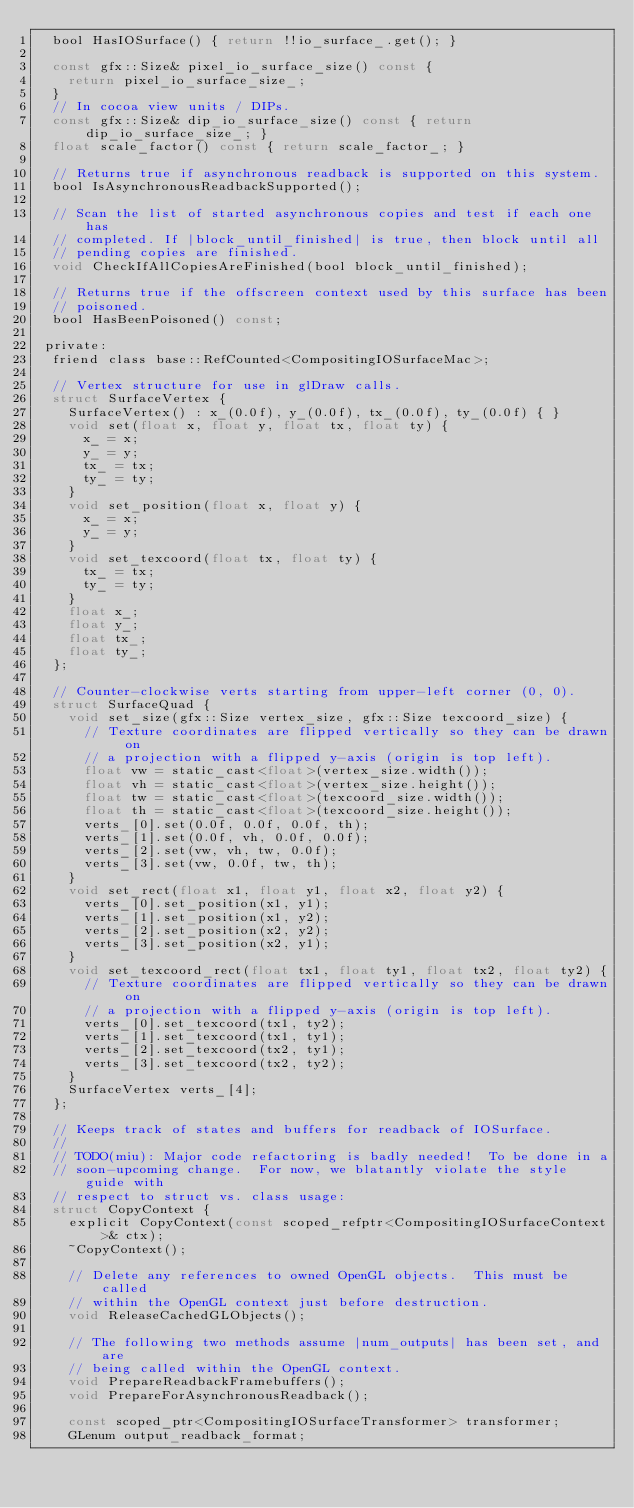Convert code to text. <code><loc_0><loc_0><loc_500><loc_500><_C_>  bool HasIOSurface() { return !!io_surface_.get(); }

  const gfx::Size& pixel_io_surface_size() const {
    return pixel_io_surface_size_;
  }
  // In cocoa view units / DIPs.
  const gfx::Size& dip_io_surface_size() const { return dip_io_surface_size_; }
  float scale_factor() const { return scale_factor_; }

  // Returns true if asynchronous readback is supported on this system.
  bool IsAsynchronousReadbackSupported();

  // Scan the list of started asynchronous copies and test if each one has
  // completed. If |block_until_finished| is true, then block until all
  // pending copies are finished.
  void CheckIfAllCopiesAreFinished(bool block_until_finished);

  // Returns true if the offscreen context used by this surface has been
  // poisoned.
  bool HasBeenPoisoned() const;

 private:
  friend class base::RefCounted<CompositingIOSurfaceMac>;

  // Vertex structure for use in glDraw calls.
  struct SurfaceVertex {
    SurfaceVertex() : x_(0.0f), y_(0.0f), tx_(0.0f), ty_(0.0f) { }
    void set(float x, float y, float tx, float ty) {
      x_ = x;
      y_ = y;
      tx_ = tx;
      ty_ = ty;
    }
    void set_position(float x, float y) {
      x_ = x;
      y_ = y;
    }
    void set_texcoord(float tx, float ty) {
      tx_ = tx;
      ty_ = ty;
    }
    float x_;
    float y_;
    float tx_;
    float ty_;
  };

  // Counter-clockwise verts starting from upper-left corner (0, 0).
  struct SurfaceQuad {
    void set_size(gfx::Size vertex_size, gfx::Size texcoord_size) {
      // Texture coordinates are flipped vertically so they can be drawn on
      // a projection with a flipped y-axis (origin is top left).
      float vw = static_cast<float>(vertex_size.width());
      float vh = static_cast<float>(vertex_size.height());
      float tw = static_cast<float>(texcoord_size.width());
      float th = static_cast<float>(texcoord_size.height());
      verts_[0].set(0.0f, 0.0f, 0.0f, th);
      verts_[1].set(0.0f, vh, 0.0f, 0.0f);
      verts_[2].set(vw, vh, tw, 0.0f);
      verts_[3].set(vw, 0.0f, tw, th);
    }
    void set_rect(float x1, float y1, float x2, float y2) {
      verts_[0].set_position(x1, y1);
      verts_[1].set_position(x1, y2);
      verts_[2].set_position(x2, y2);
      verts_[3].set_position(x2, y1);
    }
    void set_texcoord_rect(float tx1, float ty1, float tx2, float ty2) {
      // Texture coordinates are flipped vertically so they can be drawn on
      // a projection with a flipped y-axis (origin is top left).
      verts_[0].set_texcoord(tx1, ty2);
      verts_[1].set_texcoord(tx1, ty1);
      verts_[2].set_texcoord(tx2, ty1);
      verts_[3].set_texcoord(tx2, ty2);
    }
    SurfaceVertex verts_[4];
  };

  // Keeps track of states and buffers for readback of IOSurface.
  //
  // TODO(miu): Major code refactoring is badly needed!  To be done in a
  // soon-upcoming change.  For now, we blatantly violate the style guide with
  // respect to struct vs. class usage:
  struct CopyContext {
    explicit CopyContext(const scoped_refptr<CompositingIOSurfaceContext>& ctx);
    ~CopyContext();

    // Delete any references to owned OpenGL objects.  This must be called
    // within the OpenGL context just before destruction.
    void ReleaseCachedGLObjects();

    // The following two methods assume |num_outputs| has been set, and are
    // being called within the OpenGL context.
    void PrepareReadbackFramebuffers();
    void PrepareForAsynchronousReadback();

    const scoped_ptr<CompositingIOSurfaceTransformer> transformer;
    GLenum output_readback_format;</code> 